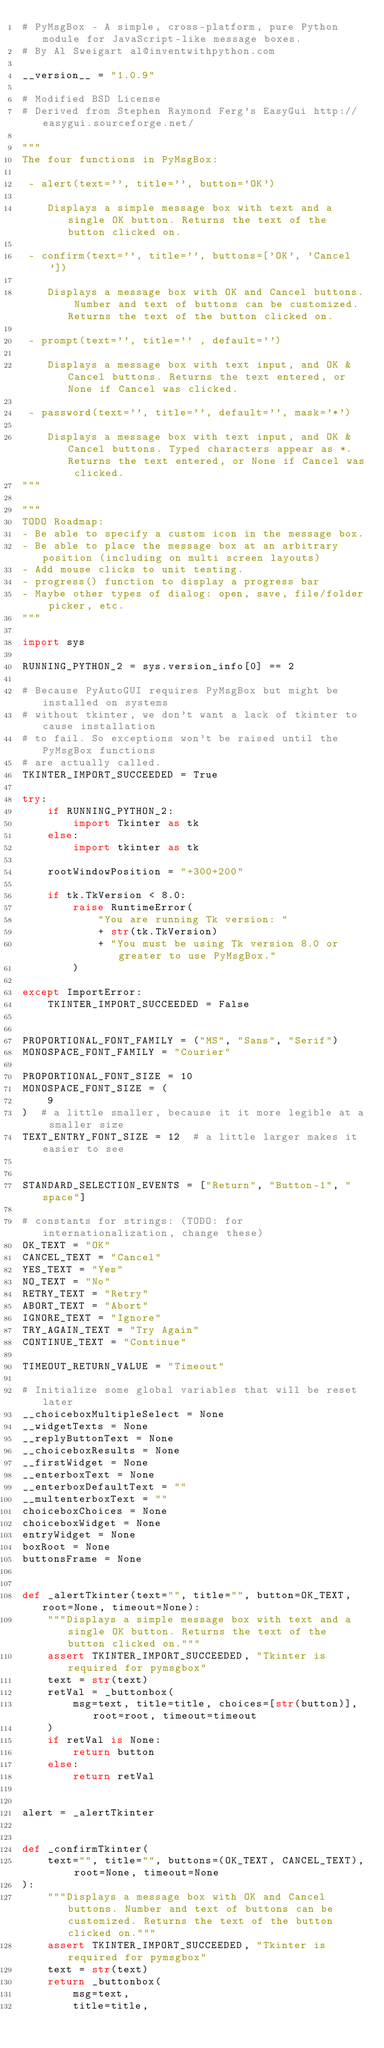<code> <loc_0><loc_0><loc_500><loc_500><_Python_># PyMsgBox - A simple, cross-platform, pure Python module for JavaScript-like message boxes.
# By Al Sweigart al@inventwithpython.com

__version__ = "1.0.9"

# Modified BSD License
# Derived from Stephen Raymond Ferg's EasyGui http://easygui.sourceforge.net/

"""
The four functions in PyMsgBox:

 - alert(text='', title='', button='OK')

    Displays a simple message box with text and a single OK button. Returns the text of the button clicked on.

 - confirm(text='', title='', buttons=['OK', 'Cancel'])

    Displays a message box with OK and Cancel buttons. Number and text of buttons can be customized. Returns the text of the button clicked on.

 - prompt(text='', title='' , default='')

    Displays a message box with text input, and OK & Cancel buttons. Returns the text entered, or None if Cancel was clicked.

 - password(text='', title='', default='', mask='*')

    Displays a message box with text input, and OK & Cancel buttons. Typed characters appear as *. Returns the text entered, or None if Cancel was clicked.
"""

"""
TODO Roadmap:
- Be able to specify a custom icon in the message box.
- Be able to place the message box at an arbitrary position (including on multi screen layouts)
- Add mouse clicks to unit testing.
- progress() function to display a progress bar
- Maybe other types of dialog: open, save, file/folder picker, etc.
"""

import sys

RUNNING_PYTHON_2 = sys.version_info[0] == 2

# Because PyAutoGUI requires PyMsgBox but might be installed on systems
# without tkinter, we don't want a lack of tkinter to cause installation
# to fail. So exceptions won't be raised until the PyMsgBox functions
# are actually called.
TKINTER_IMPORT_SUCCEEDED = True

try:
    if RUNNING_PYTHON_2:
        import Tkinter as tk
    else:
        import tkinter as tk

    rootWindowPosition = "+300+200"

    if tk.TkVersion < 8.0:
        raise RuntimeError(
            "You are running Tk version: "
            + str(tk.TkVersion)
            + "You must be using Tk version 8.0 or greater to use PyMsgBox."
        )

except ImportError:
    TKINTER_IMPORT_SUCCEEDED = False


PROPORTIONAL_FONT_FAMILY = ("MS", "Sans", "Serif")
MONOSPACE_FONT_FAMILY = "Courier"

PROPORTIONAL_FONT_SIZE = 10
MONOSPACE_FONT_SIZE = (
    9
)  # a little smaller, because it it more legible at a smaller size
TEXT_ENTRY_FONT_SIZE = 12  # a little larger makes it easier to see


STANDARD_SELECTION_EVENTS = ["Return", "Button-1", "space"]

# constants for strings: (TODO: for internationalization, change these)
OK_TEXT = "OK"
CANCEL_TEXT = "Cancel"
YES_TEXT = "Yes"
NO_TEXT = "No"
RETRY_TEXT = "Retry"
ABORT_TEXT = "Abort"
IGNORE_TEXT = "Ignore"
TRY_AGAIN_TEXT = "Try Again"
CONTINUE_TEXT = "Continue"

TIMEOUT_RETURN_VALUE = "Timeout"

# Initialize some global variables that will be reset later
__choiceboxMultipleSelect = None
__widgetTexts = None
__replyButtonText = None
__choiceboxResults = None
__firstWidget = None
__enterboxText = None
__enterboxDefaultText = ""
__multenterboxText = ""
choiceboxChoices = None
choiceboxWidget = None
entryWidget = None
boxRoot = None
buttonsFrame = None


def _alertTkinter(text="", title="", button=OK_TEXT, root=None, timeout=None):
    """Displays a simple message box with text and a single OK button. Returns the text of the button clicked on."""
    assert TKINTER_IMPORT_SUCCEEDED, "Tkinter is required for pymsgbox"
    text = str(text)
    retVal = _buttonbox(
        msg=text, title=title, choices=[str(button)], root=root, timeout=timeout
    )
    if retVal is None:
        return button
    else:
        return retVal


alert = _alertTkinter


def _confirmTkinter(
    text="", title="", buttons=(OK_TEXT, CANCEL_TEXT), root=None, timeout=None
):
    """Displays a message box with OK and Cancel buttons. Number and text of buttons can be customized. Returns the text of the button clicked on."""
    assert TKINTER_IMPORT_SUCCEEDED, "Tkinter is required for pymsgbox"
    text = str(text)
    return _buttonbox(
        msg=text,
        title=title,</code> 